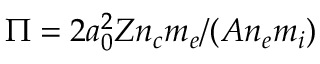Convert formula to latex. <formula><loc_0><loc_0><loc_500><loc_500>\Pi = 2 a _ { 0 } ^ { 2 } Z n _ { c } m _ { e } / ( A n _ { e } m _ { i } )</formula> 